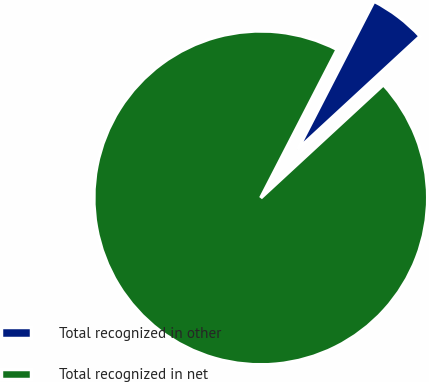Convert chart. <chart><loc_0><loc_0><loc_500><loc_500><pie_chart><fcel>Total recognized in other<fcel>Total recognized in net<nl><fcel>5.56%<fcel>94.44%<nl></chart> 